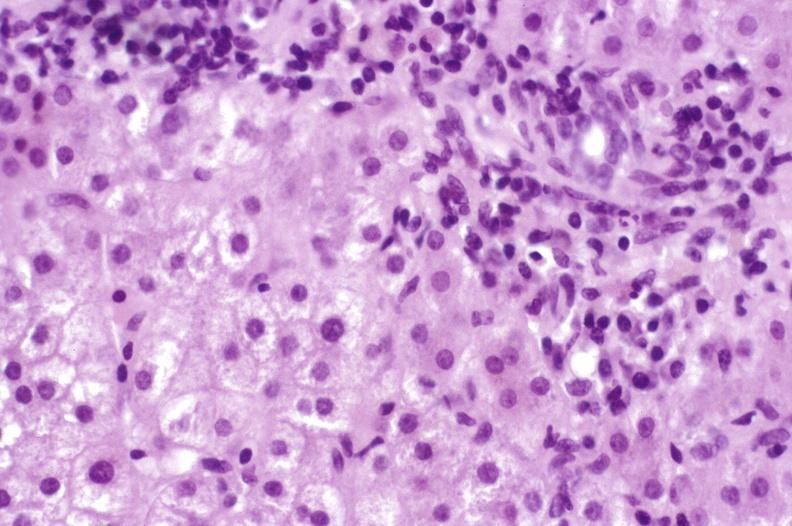s liver present?
Answer the question using a single word or phrase. Yes 